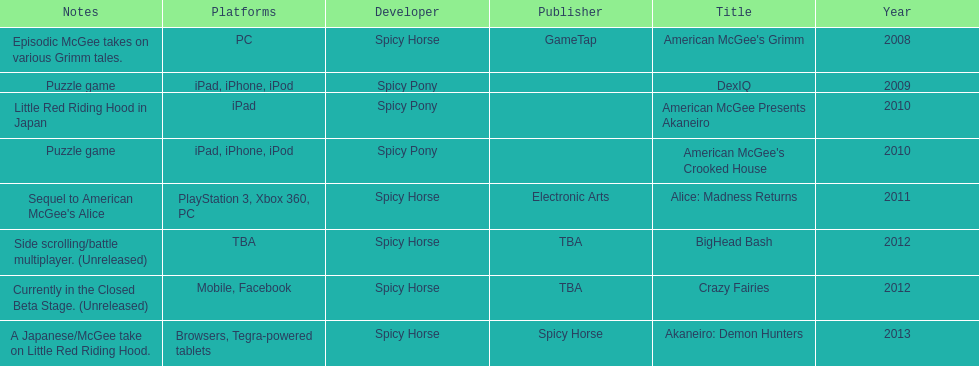What platform was used for the last title on this chart? Browsers, Tegra-powered tablets. 